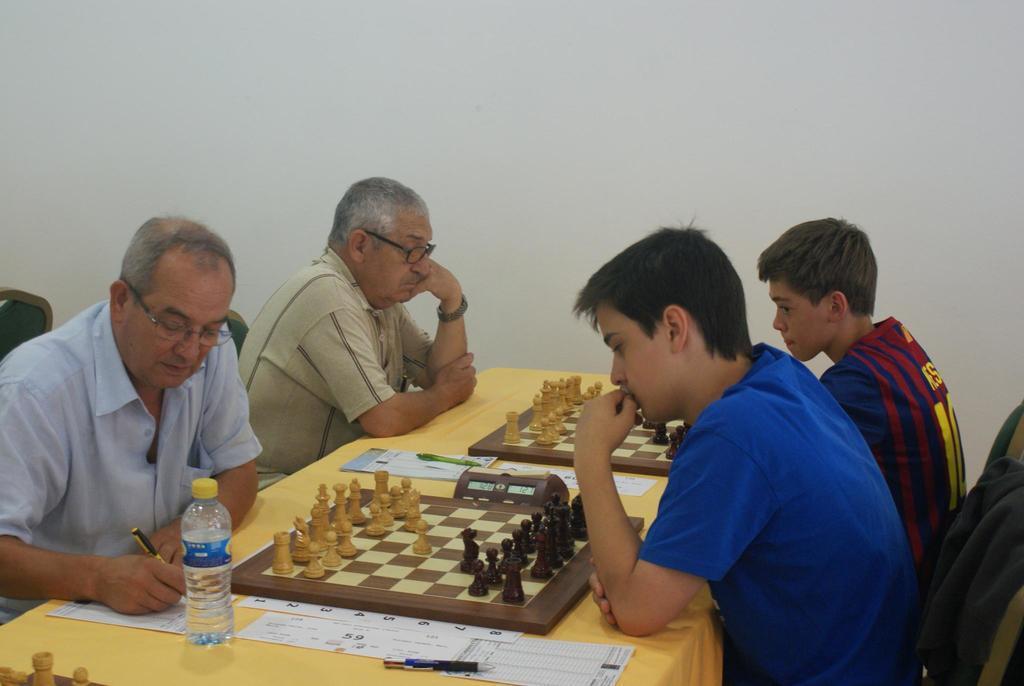How would you summarize this image in a sentence or two? There are 4 men sitting on the chair at the table and playing chess game. On the table there is a water bottle,pens,paper,chess boards and coins. In the background there is a wall. 